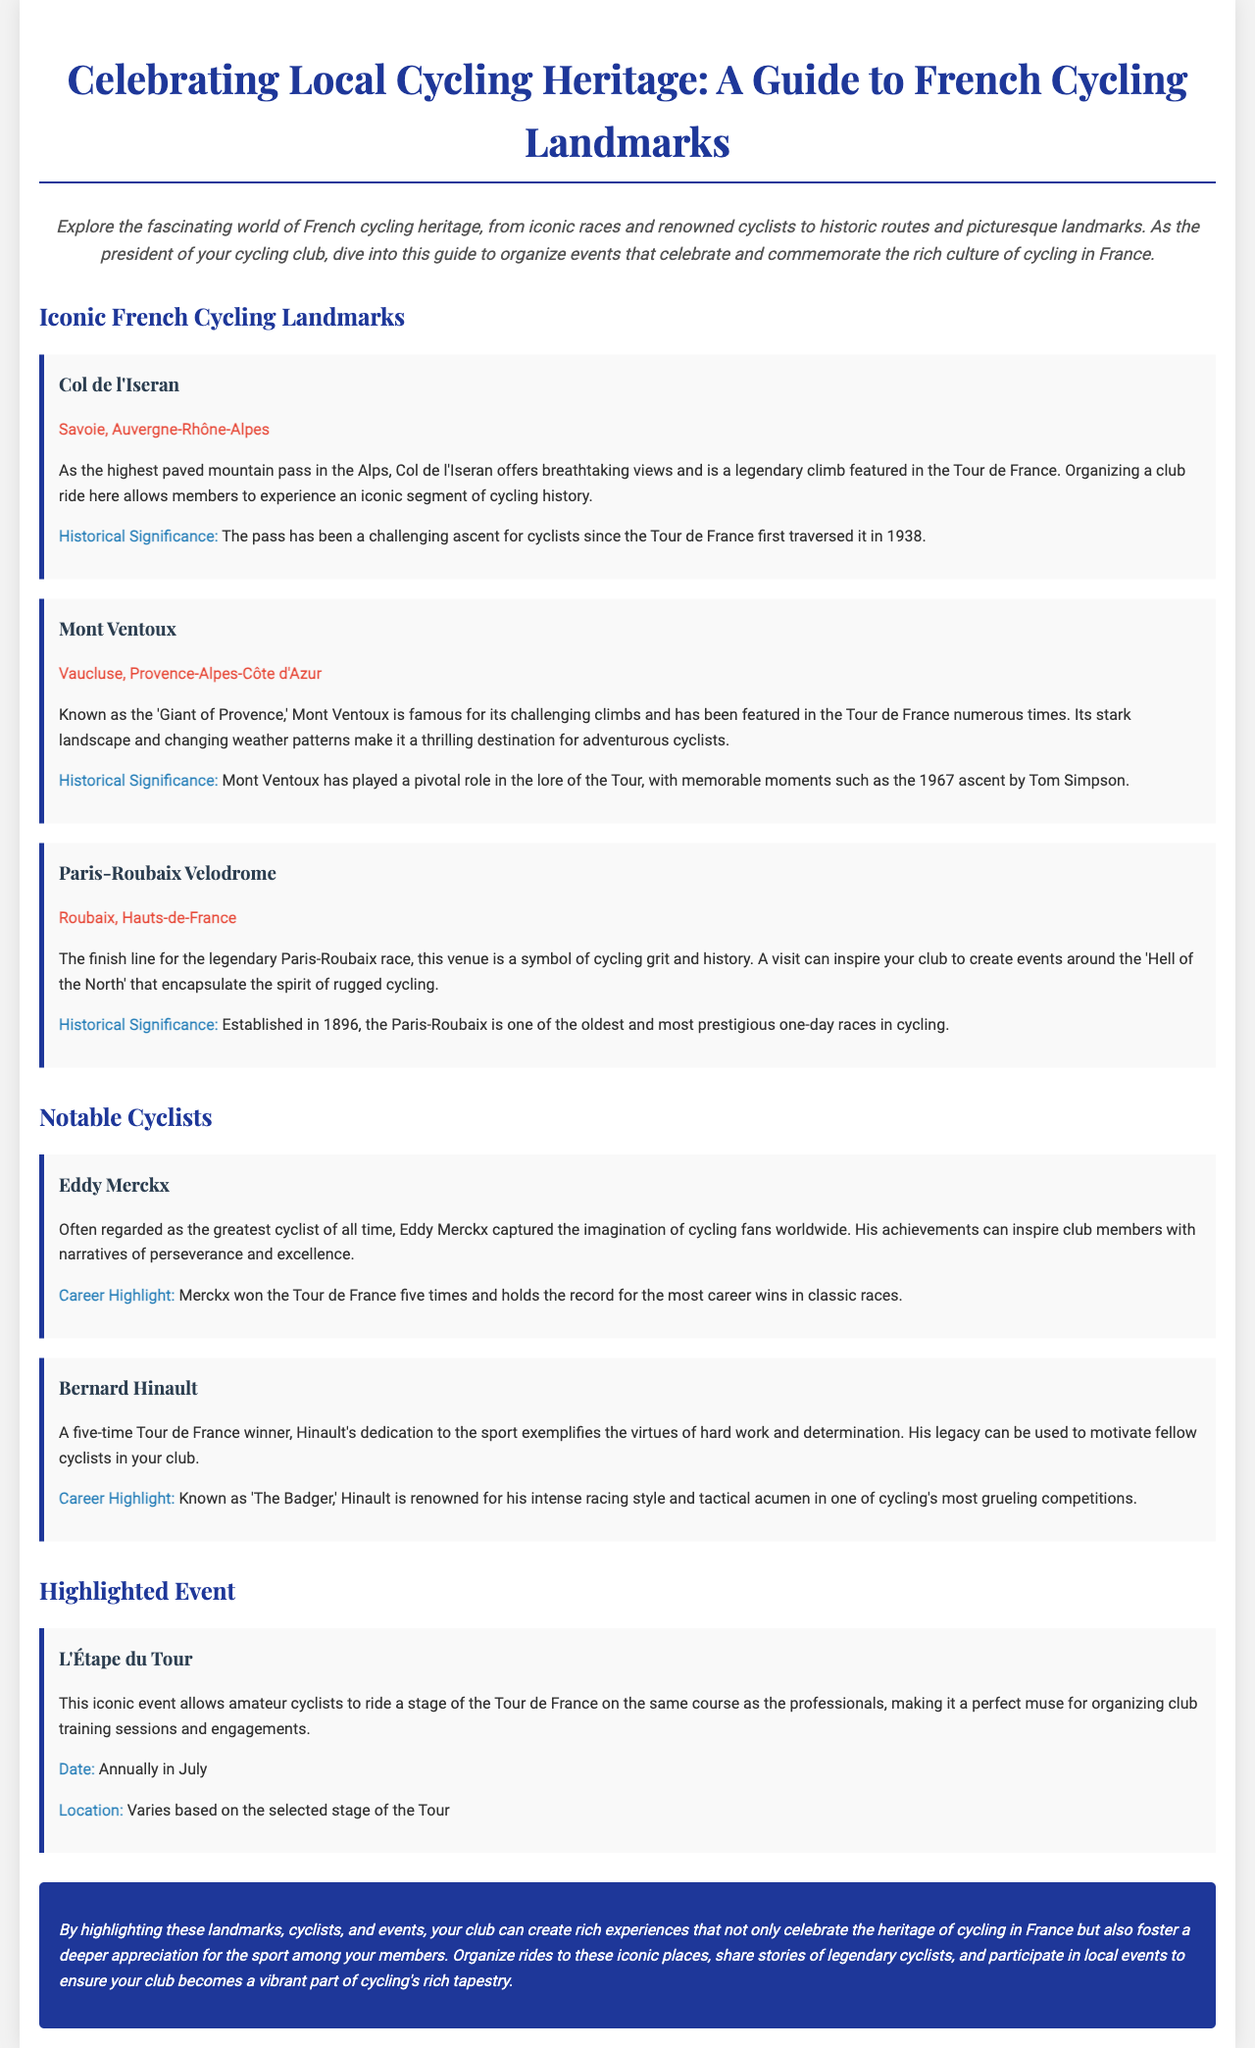what is the highest paved mountain pass in the Alps? The document states that Col de l'Iseran is the highest paved mountain pass in the Alps.
Answer: Col de l'Iseran which mountain is known as the 'Giant of Provence'? The document mentions that Mont Ventoux is referred to as the 'Giant of Provence'.
Answer: Mont Ventoux what year was Paris-Roubaix established? The document specifies that Paris-Roubaix was established in 1896.
Answer: 1896 who is often regarded as the greatest cyclist of all time? According to the document, Eddy Merckx is often regarded as the greatest cyclist of all time.
Answer: Eddy Merckx what is the highlight event of amateur cyclists riding a stage of the Tour de France? The brochure highlights L'Étape du Tour as the event for amateur cyclists.
Answer: L'Étape du Tour how many times did Eddy Merckx win the Tour de France? The document states that Eddy Merckx won the Tour de France five times.
Answer: five what does Mont Ventoux's landscape make it suitable for? The document describes Mont Ventoux's stark landscape and changing weather as making it a thrilling destination for adventurous cyclists.
Answer: adventurous cyclists when does L'Étape du Tour usually occur? The document mentions that L'Étape du Tour takes place annually in July.
Answer: annually in July 